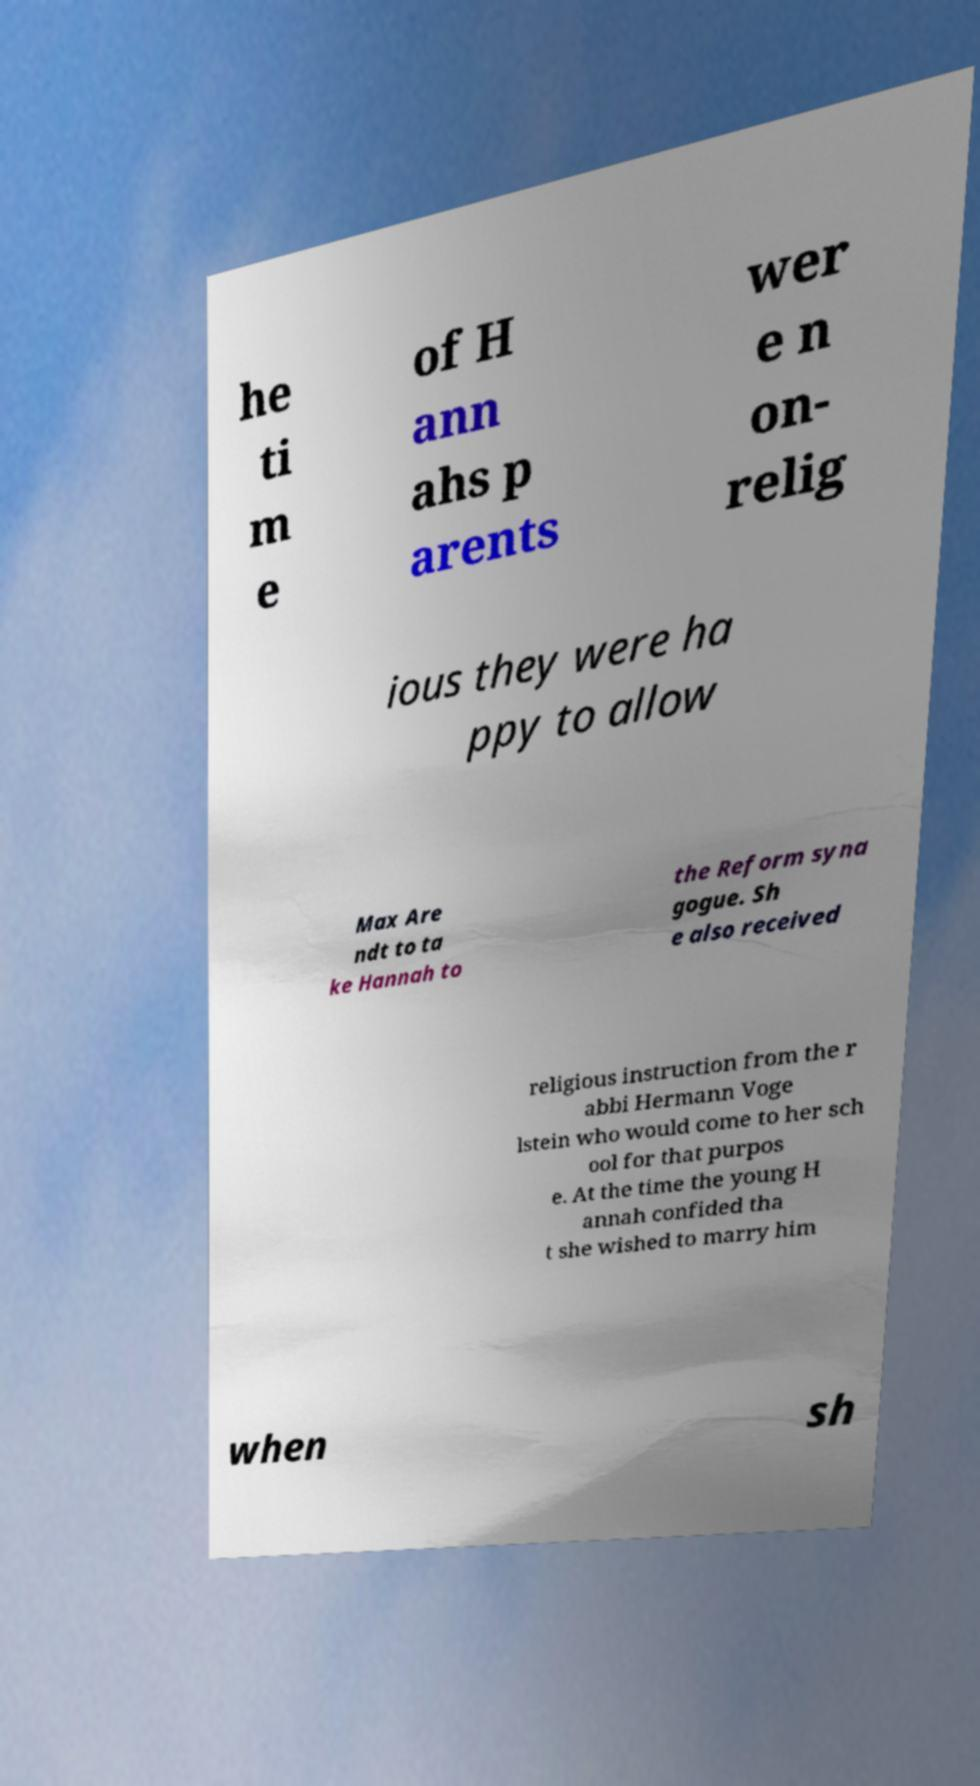Can you accurately transcribe the text from the provided image for me? he ti m e of H ann ahs p arents wer e n on- relig ious they were ha ppy to allow Max Are ndt to ta ke Hannah to the Reform syna gogue. Sh e also received religious instruction from the r abbi Hermann Voge lstein who would come to her sch ool for that purpos e. At the time the young H annah confided tha t she wished to marry him when sh 